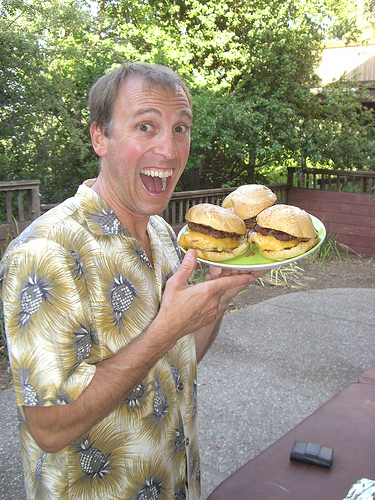<image>
Is the burger next to the wallet? No. The burger is not positioned next to the wallet. They are located in different areas of the scene. 